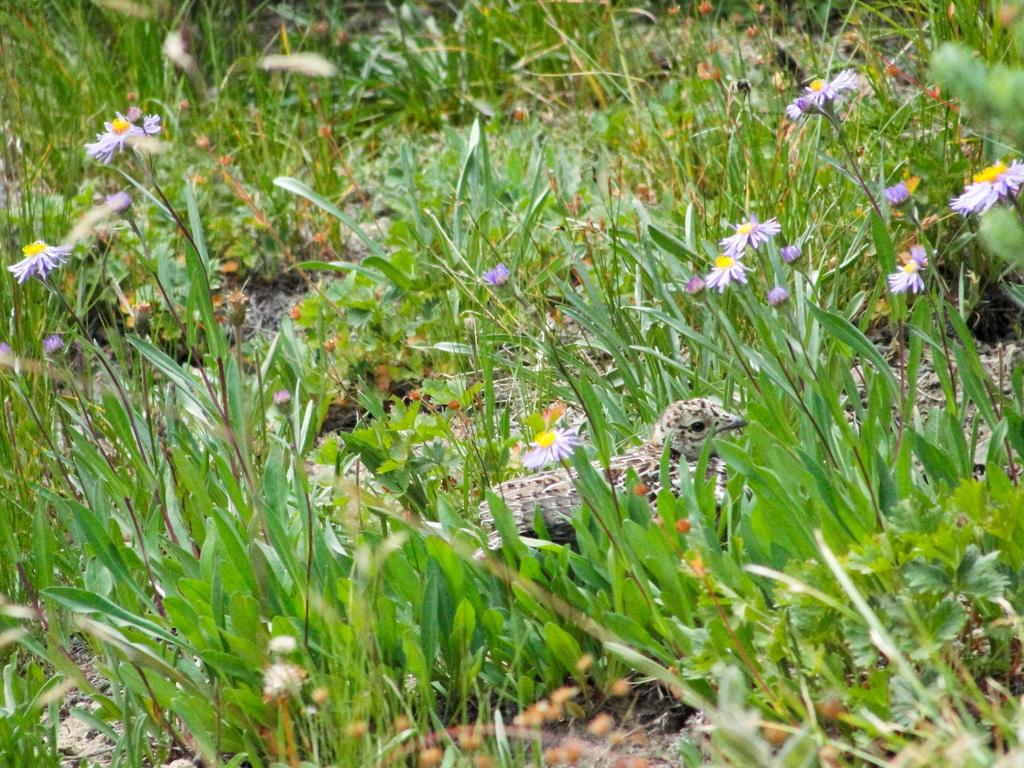What type of animal can be seen in the image? There is a bird in the image. What other living organisms are present in the image? There are plants and flowers in the image. What type of fruit is the bird holding in the image? There is no fruit present in the image, and the bird is not holding anything. 